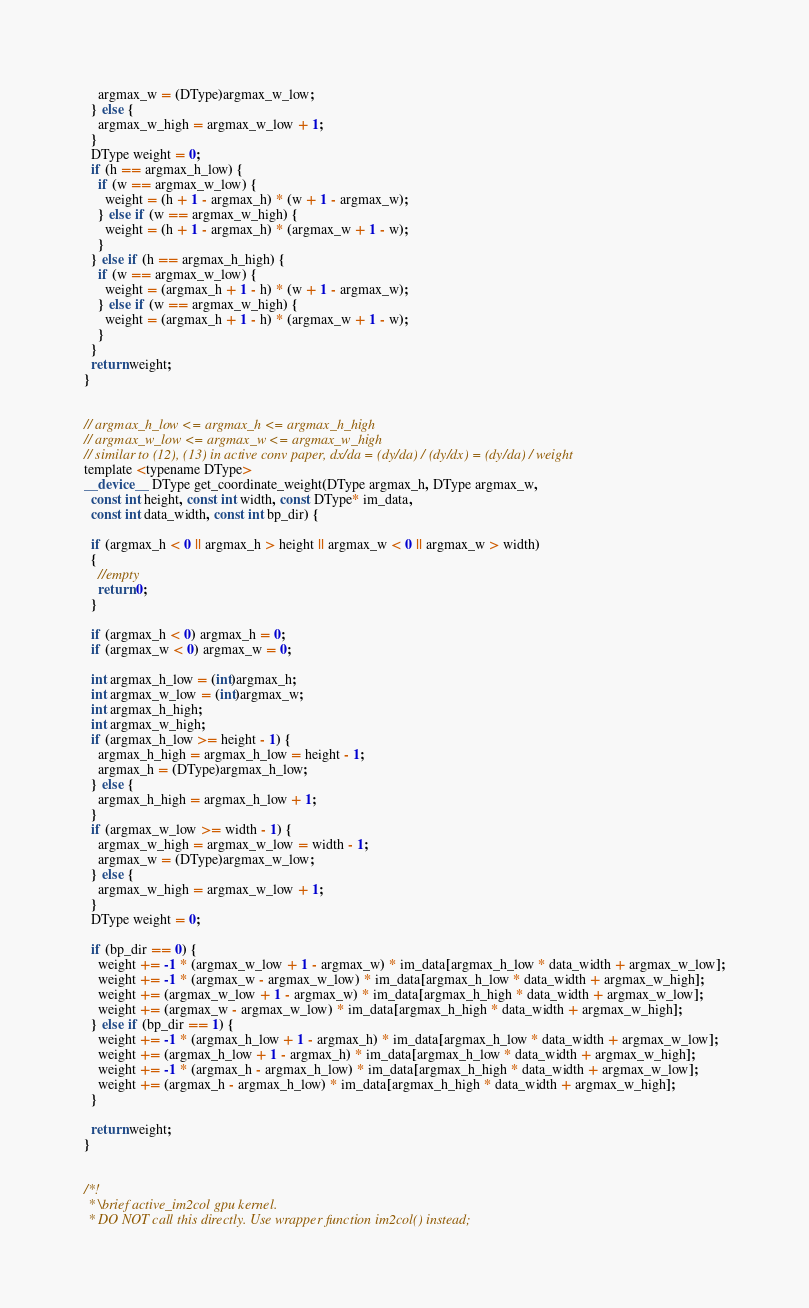Convert code to text. <code><loc_0><loc_0><loc_500><loc_500><_Cuda_>    argmax_w = (DType)argmax_w_low;
  } else {
    argmax_w_high = argmax_w_low + 1;
  }
  DType weight = 0;
  if (h == argmax_h_low) {
    if (w == argmax_w_low) {
      weight = (h + 1 - argmax_h) * (w + 1 - argmax_w);
    } else if (w == argmax_w_high) {
      weight = (h + 1 - argmax_h) * (argmax_w + 1 - w);
    }
  } else if (h == argmax_h_high) {
    if (w == argmax_w_low) {
      weight = (argmax_h + 1 - h) * (w + 1 - argmax_w);
    } else if (w == argmax_w_high) {
      weight = (argmax_h + 1 - h) * (argmax_w + 1 - w);
    }
  }
  return weight;
}


// argmax_h_low <= argmax_h <= argmax_h_high
// argmax_w_low <= argmax_w <= argmax_w_high
// similar to (12), (13) in active conv paper, dx/da = (dy/da) / (dy/dx) = (dy/da) / weight
template <typename DType>
__device__ DType get_coordinate_weight(DType argmax_h, DType argmax_w,
  const int height, const int width, const DType* im_data,
  const int data_width, const int bp_dir) {

  if (argmax_h < 0 || argmax_h > height || argmax_w < 0 || argmax_w > width)
  {
    //empty
    return 0;
  }

  if (argmax_h < 0) argmax_h = 0;
  if (argmax_w < 0) argmax_w = 0;

  int argmax_h_low = (int)argmax_h;
  int argmax_w_low = (int)argmax_w;
  int argmax_h_high;
  int argmax_w_high;
  if (argmax_h_low >= height - 1) {
    argmax_h_high = argmax_h_low = height - 1;
    argmax_h = (DType)argmax_h_low;
  } else {
    argmax_h_high = argmax_h_low + 1;
  }
  if (argmax_w_low >= width - 1) {
    argmax_w_high = argmax_w_low = width - 1;
    argmax_w = (DType)argmax_w_low;
  } else {
    argmax_w_high = argmax_w_low + 1;
  }
  DType weight = 0;

  if (bp_dir == 0) {
    weight += -1 * (argmax_w_low + 1 - argmax_w) * im_data[argmax_h_low * data_width + argmax_w_low];
    weight += -1 * (argmax_w - argmax_w_low) * im_data[argmax_h_low * data_width + argmax_w_high];
    weight += (argmax_w_low + 1 - argmax_w) * im_data[argmax_h_high * data_width + argmax_w_low];
    weight += (argmax_w - argmax_w_low) * im_data[argmax_h_high * data_width + argmax_w_high];
  } else if (bp_dir == 1) {
    weight += -1 * (argmax_h_low + 1 - argmax_h) * im_data[argmax_h_low * data_width + argmax_w_low];
    weight += (argmax_h_low + 1 - argmax_h) * im_data[argmax_h_low * data_width + argmax_w_high];
    weight += -1 * (argmax_h - argmax_h_low) * im_data[argmax_h_high * data_width + argmax_w_low];
    weight += (argmax_h - argmax_h_low) * im_data[argmax_h_high * data_width + argmax_w_high];
  }

  return weight;
}


/*!
 * \brief active_im2col gpu kernel.
 * DO NOT call this directly. Use wrapper function im2col() instead;</code> 